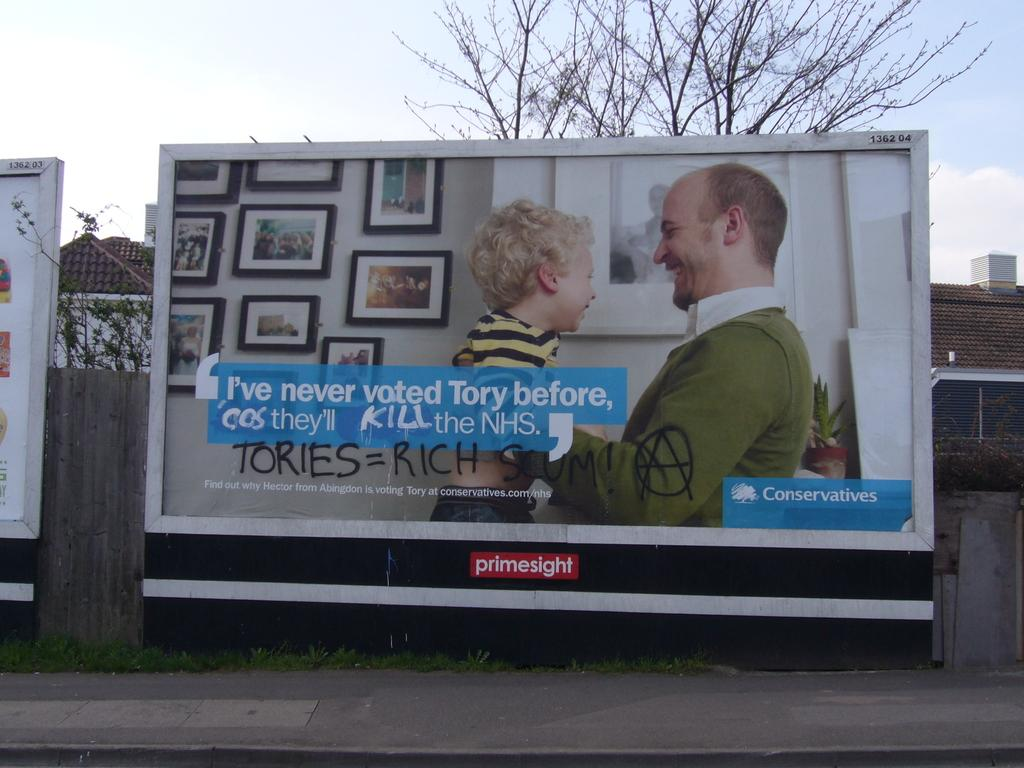<image>
Share a concise interpretation of the image provided. Someone has vandalized a billboard with the message that tories = rich. 